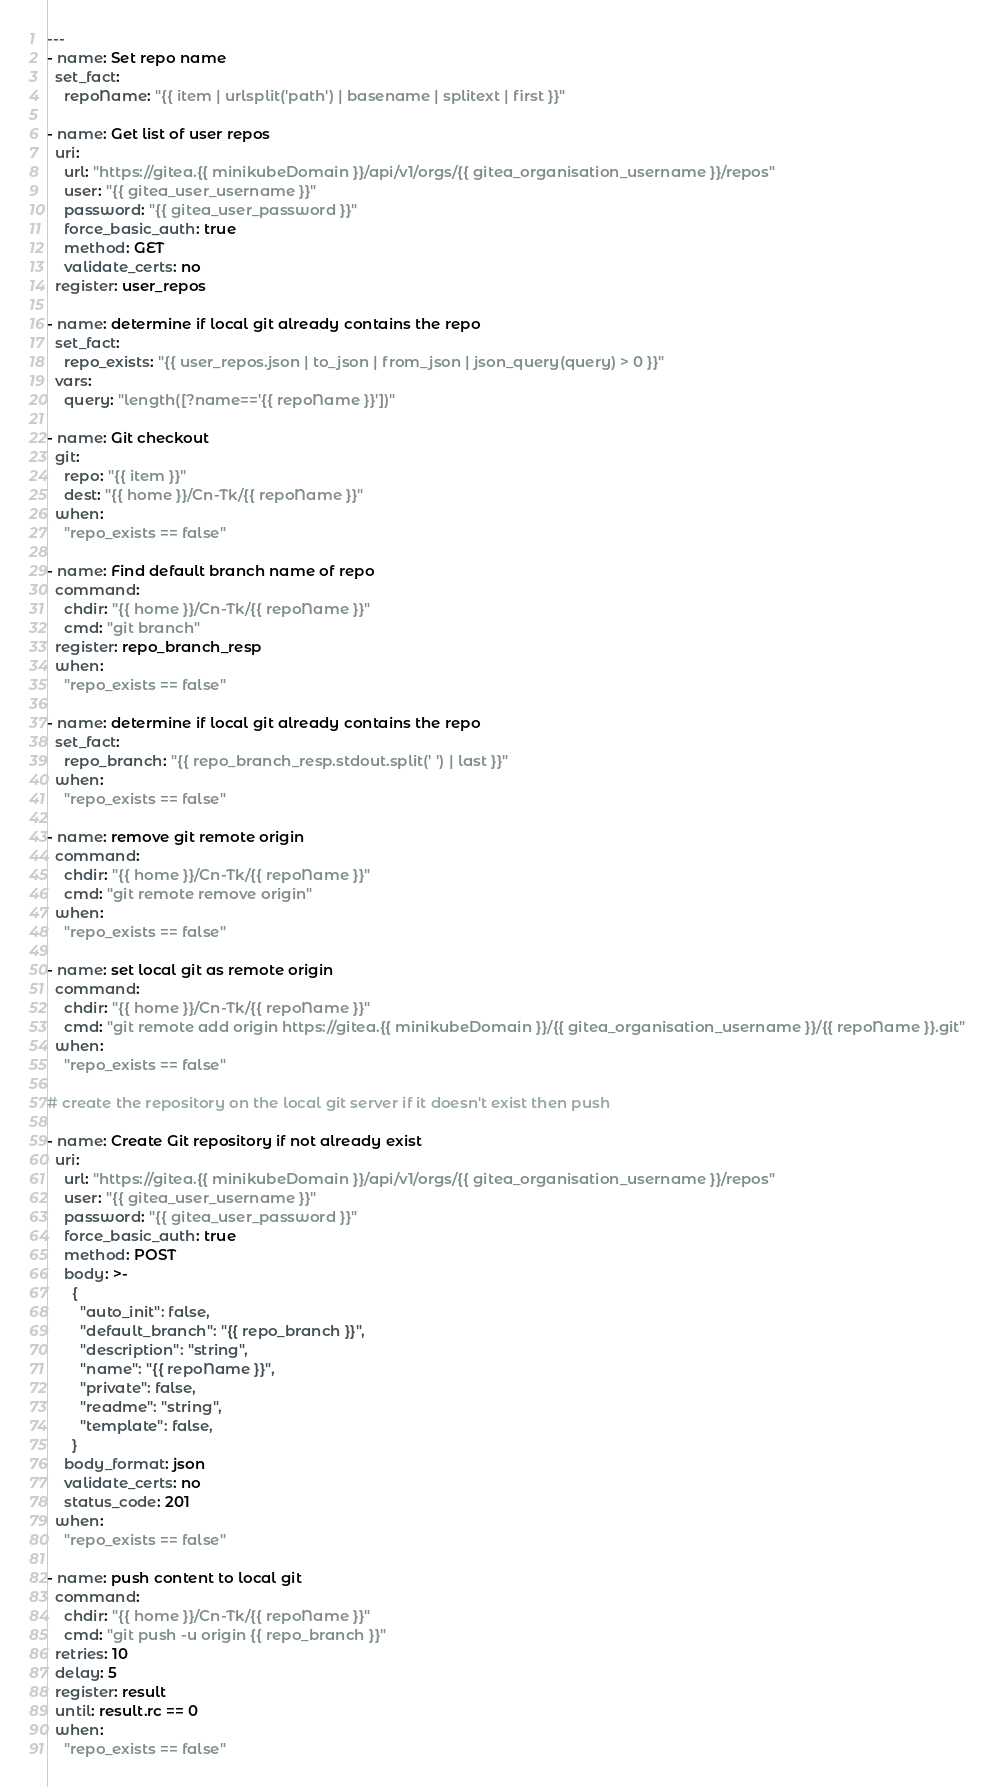Convert code to text. <code><loc_0><loc_0><loc_500><loc_500><_YAML_>---
- name: Set repo name
  set_fact: 
    repoName: "{{ item | urlsplit('path') | basename | splitext | first }}"

- name: Get list of user repos
  uri:
    url: "https://gitea.{{ minikubeDomain }}/api/v1/orgs/{{ gitea_organisation_username }}/repos"
    user: "{{ gitea_user_username }}"
    password: "{{ gitea_user_password }}"
    force_basic_auth: true
    method: GET
    validate_certs: no
  register: user_repos

- name: determine if local git already contains the repo
  set_fact:
    repo_exists: "{{ user_repos.json | to_json | from_json | json_query(query) > 0 }}"
  vars:
    query: "length([?name=='{{ repoName }}'])" 

- name: Git checkout
  git:
    repo: "{{ item }}"
    dest: "{{ home }}/Cn-Tk/{{ repoName }}"
  when: 
    "repo_exists == false"

- name: Find default branch name of repo
  command:
    chdir: "{{ home }}/Cn-Tk/{{ repoName }}"
    cmd: "git branch"
  register: repo_branch_resp
  when: 
    "repo_exists == false" 

- name: determine if local git already contains the repo
  set_fact:
    repo_branch: "{{ repo_branch_resp.stdout.split(' ') | last }}"
  when: 
    "repo_exists == false" 

- name: remove git remote origin
  command:
    chdir: "{{ home }}/Cn-Tk/{{ repoName }}"
    cmd: "git remote remove origin"
  when: 
    "repo_exists == false"

- name: set local git as remote origin
  command:
    chdir: "{{ home }}/Cn-Tk/{{ repoName }}"
    cmd: "git remote add origin https://gitea.{{ minikubeDomain }}/{{ gitea_organisation_username }}/{{ repoName }}.git"
  when: 
    "repo_exists == false"

# create the repository on the local git server if it doesn't exist then push 

- name: Create Git repository if not already exist
  uri:
    url: "https://gitea.{{ minikubeDomain }}/api/v1/orgs/{{ gitea_organisation_username }}/repos"
    user: "{{ gitea_user_username }}"
    password: "{{ gitea_user_password }}"
    force_basic_auth: true
    method: POST
    body: >-
      {
        "auto_init": false,
        "default_branch": "{{ repo_branch }}",
        "description": "string",
        "name": "{{ repoName }}",
        "private": false,
        "readme": "string",
        "template": false,
      }
    body_format: json
    validate_certs: no
    status_code: 201
  when: 
    "repo_exists == false"

- name: push content to local git
  command:
    chdir: "{{ home }}/Cn-Tk/{{ repoName }}"
    cmd: "git push -u origin {{ repo_branch }}"
  retries: 10
  delay: 5
  register: result
  until: result.rc == 0
  when: 
    "repo_exists == false"</code> 